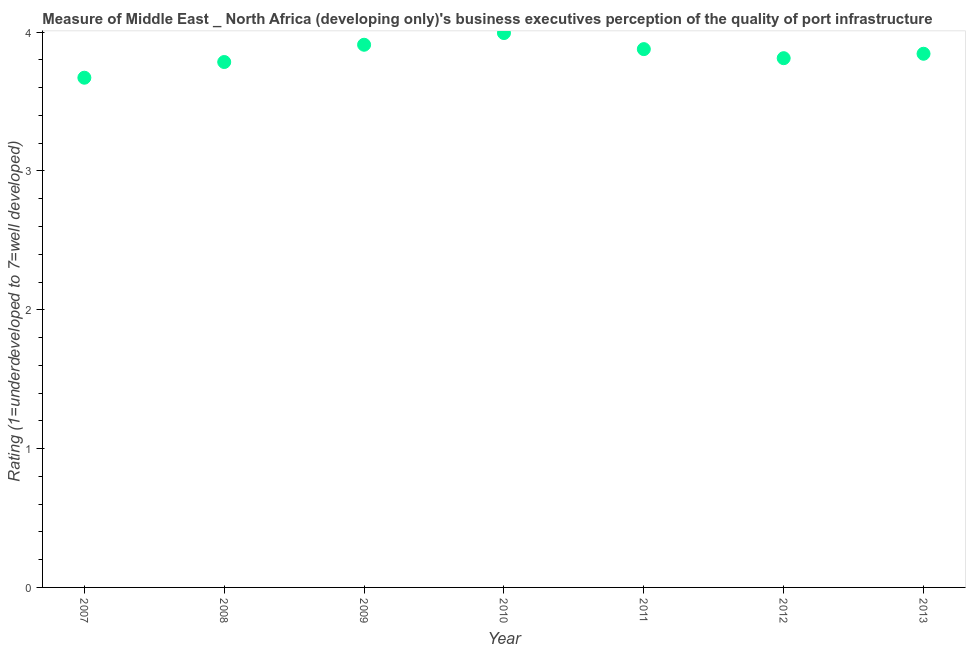What is the rating measuring quality of port infrastructure in 2008?
Provide a succinct answer. 3.78. Across all years, what is the maximum rating measuring quality of port infrastructure?
Keep it short and to the point. 3.99. Across all years, what is the minimum rating measuring quality of port infrastructure?
Provide a succinct answer. 3.67. In which year was the rating measuring quality of port infrastructure minimum?
Your response must be concise. 2007. What is the sum of the rating measuring quality of port infrastructure?
Provide a succinct answer. 26.89. What is the difference between the rating measuring quality of port infrastructure in 2011 and 2013?
Ensure brevity in your answer.  0.03. What is the average rating measuring quality of port infrastructure per year?
Ensure brevity in your answer.  3.84. What is the median rating measuring quality of port infrastructure?
Keep it short and to the point. 3.84. In how many years, is the rating measuring quality of port infrastructure greater than 2.2 ?
Provide a succinct answer. 7. What is the ratio of the rating measuring quality of port infrastructure in 2008 to that in 2009?
Ensure brevity in your answer.  0.97. Is the rating measuring quality of port infrastructure in 2007 less than that in 2011?
Provide a succinct answer. Yes. What is the difference between the highest and the second highest rating measuring quality of port infrastructure?
Offer a terse response. 0.08. Is the sum of the rating measuring quality of port infrastructure in 2008 and 2010 greater than the maximum rating measuring quality of port infrastructure across all years?
Offer a very short reply. Yes. What is the difference between the highest and the lowest rating measuring quality of port infrastructure?
Your answer should be compact. 0.32. Does the rating measuring quality of port infrastructure monotonically increase over the years?
Keep it short and to the point. No. What is the title of the graph?
Provide a succinct answer. Measure of Middle East _ North Africa (developing only)'s business executives perception of the quality of port infrastructure. What is the label or title of the Y-axis?
Give a very brief answer. Rating (1=underdeveloped to 7=well developed) . What is the Rating (1=underdeveloped to 7=well developed)  in 2007?
Make the answer very short. 3.67. What is the Rating (1=underdeveloped to 7=well developed)  in 2008?
Ensure brevity in your answer.  3.78. What is the Rating (1=underdeveloped to 7=well developed)  in 2009?
Ensure brevity in your answer.  3.91. What is the Rating (1=underdeveloped to 7=well developed)  in 2010?
Provide a short and direct response. 3.99. What is the Rating (1=underdeveloped to 7=well developed)  in 2011?
Ensure brevity in your answer.  3.88. What is the Rating (1=underdeveloped to 7=well developed)  in 2012?
Provide a succinct answer. 3.81. What is the Rating (1=underdeveloped to 7=well developed)  in 2013?
Your response must be concise. 3.84. What is the difference between the Rating (1=underdeveloped to 7=well developed)  in 2007 and 2008?
Offer a terse response. -0.11. What is the difference between the Rating (1=underdeveloped to 7=well developed)  in 2007 and 2009?
Your answer should be very brief. -0.24. What is the difference between the Rating (1=underdeveloped to 7=well developed)  in 2007 and 2010?
Ensure brevity in your answer.  -0.32. What is the difference between the Rating (1=underdeveloped to 7=well developed)  in 2007 and 2011?
Offer a very short reply. -0.21. What is the difference between the Rating (1=underdeveloped to 7=well developed)  in 2007 and 2012?
Make the answer very short. -0.14. What is the difference between the Rating (1=underdeveloped to 7=well developed)  in 2007 and 2013?
Your answer should be compact. -0.17. What is the difference between the Rating (1=underdeveloped to 7=well developed)  in 2008 and 2009?
Offer a very short reply. -0.12. What is the difference between the Rating (1=underdeveloped to 7=well developed)  in 2008 and 2010?
Make the answer very short. -0.21. What is the difference between the Rating (1=underdeveloped to 7=well developed)  in 2008 and 2011?
Give a very brief answer. -0.09. What is the difference between the Rating (1=underdeveloped to 7=well developed)  in 2008 and 2012?
Ensure brevity in your answer.  -0.03. What is the difference between the Rating (1=underdeveloped to 7=well developed)  in 2008 and 2013?
Keep it short and to the point. -0.06. What is the difference between the Rating (1=underdeveloped to 7=well developed)  in 2009 and 2010?
Keep it short and to the point. -0.08. What is the difference between the Rating (1=underdeveloped to 7=well developed)  in 2009 and 2011?
Ensure brevity in your answer.  0.03. What is the difference between the Rating (1=underdeveloped to 7=well developed)  in 2009 and 2012?
Ensure brevity in your answer.  0.1. What is the difference between the Rating (1=underdeveloped to 7=well developed)  in 2009 and 2013?
Offer a terse response. 0.06. What is the difference between the Rating (1=underdeveloped to 7=well developed)  in 2010 and 2011?
Make the answer very short. 0.12. What is the difference between the Rating (1=underdeveloped to 7=well developed)  in 2010 and 2012?
Provide a succinct answer. 0.18. What is the difference between the Rating (1=underdeveloped to 7=well developed)  in 2010 and 2013?
Your answer should be compact. 0.15. What is the difference between the Rating (1=underdeveloped to 7=well developed)  in 2011 and 2012?
Provide a succinct answer. 0.07. What is the difference between the Rating (1=underdeveloped to 7=well developed)  in 2011 and 2013?
Your response must be concise. 0.03. What is the difference between the Rating (1=underdeveloped to 7=well developed)  in 2012 and 2013?
Offer a terse response. -0.03. What is the ratio of the Rating (1=underdeveloped to 7=well developed)  in 2007 to that in 2008?
Your answer should be compact. 0.97. What is the ratio of the Rating (1=underdeveloped to 7=well developed)  in 2007 to that in 2009?
Your answer should be compact. 0.94. What is the ratio of the Rating (1=underdeveloped to 7=well developed)  in 2007 to that in 2010?
Make the answer very short. 0.92. What is the ratio of the Rating (1=underdeveloped to 7=well developed)  in 2007 to that in 2011?
Offer a very short reply. 0.95. What is the ratio of the Rating (1=underdeveloped to 7=well developed)  in 2007 to that in 2013?
Make the answer very short. 0.95. What is the ratio of the Rating (1=underdeveloped to 7=well developed)  in 2008 to that in 2010?
Keep it short and to the point. 0.95. What is the ratio of the Rating (1=underdeveloped to 7=well developed)  in 2008 to that in 2013?
Your response must be concise. 0.98. What is the ratio of the Rating (1=underdeveloped to 7=well developed)  in 2009 to that in 2011?
Offer a very short reply. 1.01. What is the ratio of the Rating (1=underdeveloped to 7=well developed)  in 2009 to that in 2012?
Your answer should be compact. 1.02. What is the ratio of the Rating (1=underdeveloped to 7=well developed)  in 2010 to that in 2011?
Provide a short and direct response. 1.03. What is the ratio of the Rating (1=underdeveloped to 7=well developed)  in 2010 to that in 2012?
Offer a very short reply. 1.05. What is the ratio of the Rating (1=underdeveloped to 7=well developed)  in 2010 to that in 2013?
Your answer should be very brief. 1.04. What is the ratio of the Rating (1=underdeveloped to 7=well developed)  in 2011 to that in 2012?
Your answer should be compact. 1.02. What is the ratio of the Rating (1=underdeveloped to 7=well developed)  in 2011 to that in 2013?
Offer a terse response. 1.01. What is the ratio of the Rating (1=underdeveloped to 7=well developed)  in 2012 to that in 2013?
Make the answer very short. 0.99. 